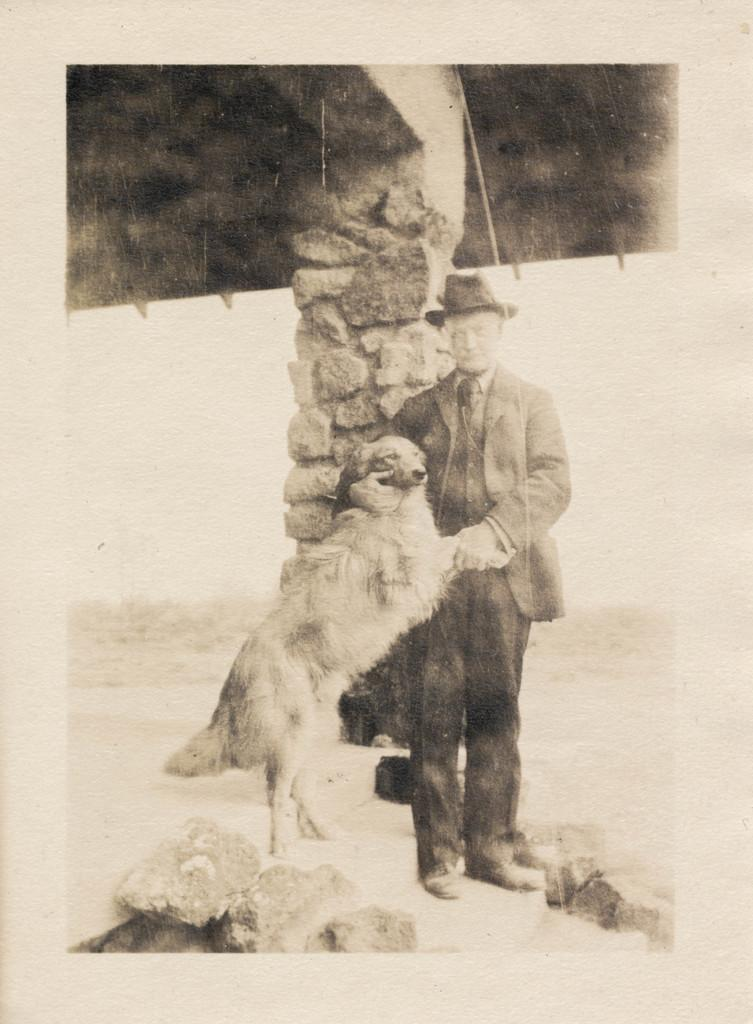What type of image is present in the picture? The image contains an old photograph. Can you describe the person in the photograph? There is a person standing in the photograph. What is the person holding in the photograph? The person is holding a dog in the photograph. What can be seen on the ground in the photograph? There are rocks on the ground in the photograph. What is visible in the background of the photograph? There is a wall and trees in the background of the photograph. What is the taste of the locket in the image? There is no locket present in the image, so it cannot be tasted or have a taste. 